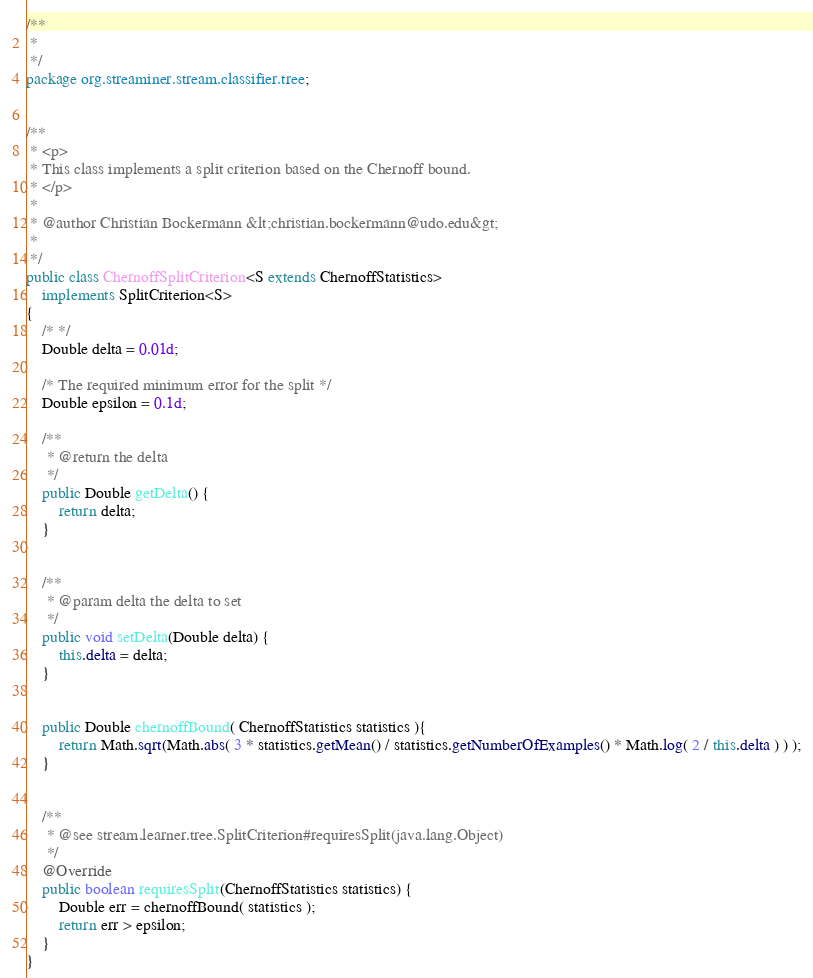Convert code to text. <code><loc_0><loc_0><loc_500><loc_500><_Java_>/**
 * 
 */
package org.streaminer.stream.classifier.tree;


/**
 * <p>
 * This class implements a split criterion based on the Chernoff bound.
 * </p>
 * 
 * @author Christian Bockermann &lt;christian.bockermann@udo.edu&gt;
 *
 */
public class ChernoffSplitCriterion<S extends ChernoffStatistics> 
	implements SplitCriterion<S> 
{
	/* */
	Double delta = 0.01d;
	
	/* The required minimum error for the split */
	Double epsilon = 0.1d;
	
	/**
	 * @return the delta
	 */
	public Double getDelta() {
		return delta;
	}


	/**
	 * @param delta the delta to set
	 */
	public void setDelta(Double delta) {
		this.delta = delta;
	}


	public Double chernoffBound( ChernoffStatistics statistics ){
		return Math.sqrt(Math.abs( 3 * statistics.getMean() / statistics.getNumberOfExamples() * Math.log( 2 / this.delta ) ) );
	}


	/**
	 * @see stream.learner.tree.SplitCriterion#requiresSplit(java.lang.Object)
	 */
	@Override
	public boolean requiresSplit(ChernoffStatistics statistics) {
		Double err = chernoffBound( statistics );
		return err > epsilon;
	}
}</code> 